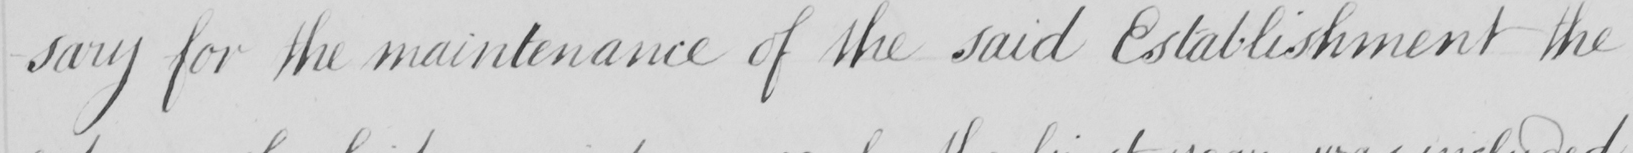Can you read and transcribe this handwriting? -sary for the maintenance of the said Establishment the 